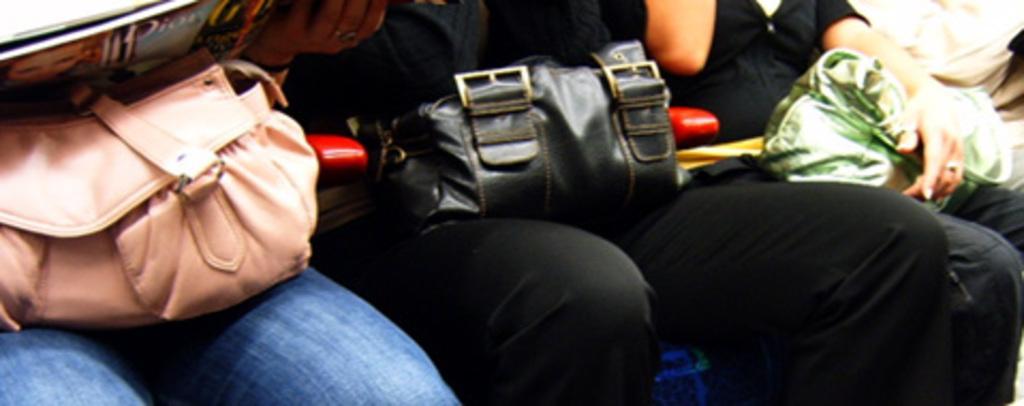How would you summarize this image in a sentence or two? In this picture there are three persons sitting on a chair. A peach color bag, black bag and a green bag is seen in the image. 